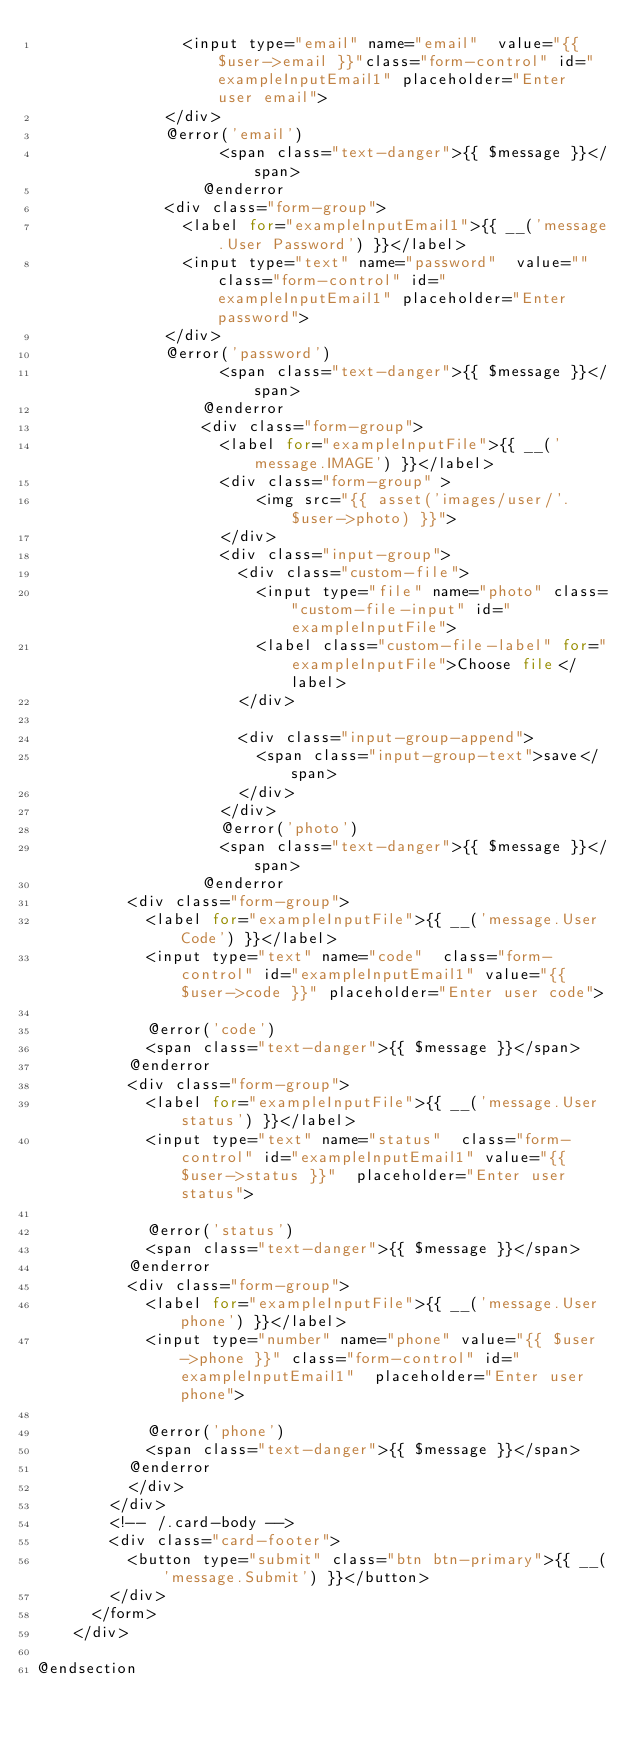Convert code to text. <code><loc_0><loc_0><loc_500><loc_500><_PHP_>                <input type="email" name="email"  value="{{ $user->email }}"class="form-control" id="exampleInputEmail1" placeholder="Enter user email">
              </div>
              @error('email')
                    <span class="text-danger">{{ $message }}</span>
                  @enderror
              <div class="form-group">
                <label for="exampleInputEmail1">{{ __('message.User Password') }}</label>
                <input type="text" name="password"  value="" class="form-control" id="exampleInputEmail1" placeholder="Enter password">
              </div>
              @error('password')
                    <span class="text-danger">{{ $message }}</span>
                  @enderror
                  <div class="form-group">
                    <label for="exampleInputFile">{{ __('message.IMAGE') }}</label>
                    <div class="form-group" >
                        <img src="{{ asset('images/user/'.$user->photo) }}">
                    </div>
                    <div class="input-group">
                      <div class="custom-file">
                        <input type="file" name="photo" class="custom-file-input" id="exampleInputFile">
                        <label class="custom-file-label" for="exampleInputFile">Choose file</label>
                      </div>

                      <div class="input-group-append">
                        <span class="input-group-text">save</span>
                      </div>
                    </div>
                    @error('photo')
                    <span class="text-danger">{{ $message }}</span>
                  @enderror
          <div class="form-group">
            <label for="exampleInputFile">{{ __('message.User Code') }}</label>
            <input type="text" name="code"  class="form-control" id="exampleInputEmail1" value="{{ $user->code }}" placeholder="Enter user code">

            @error('code')
            <span class="text-danger">{{ $message }}</span>
          @enderror
          <div class="form-group">
            <label for="exampleInputFile">{{ __('message.User status') }}</label>
            <input type="text" name="status"  class="form-control" id="exampleInputEmail1" value="{{ $user->status }}"  placeholder="Enter user status">

            @error('status')
            <span class="text-danger">{{ $message }}</span>
          @enderror
          <div class="form-group">
            <label for="exampleInputFile">{{ __('message.User phone') }}</label>
            <input type="number" name="phone" value="{{ $user->phone }}" class="form-control" id="exampleInputEmail1"  placeholder="Enter user phone">

            @error('phone')
            <span class="text-danger">{{ $message }}</span>
          @enderror
          </div>
        </div>
        <!-- /.card-body -->
        <div class="card-footer">
          <button type="submit" class="btn btn-primary">{{ __('message.Submit') }}</button>
        </div>
      </form>
    </div>

@endsection
</code> 